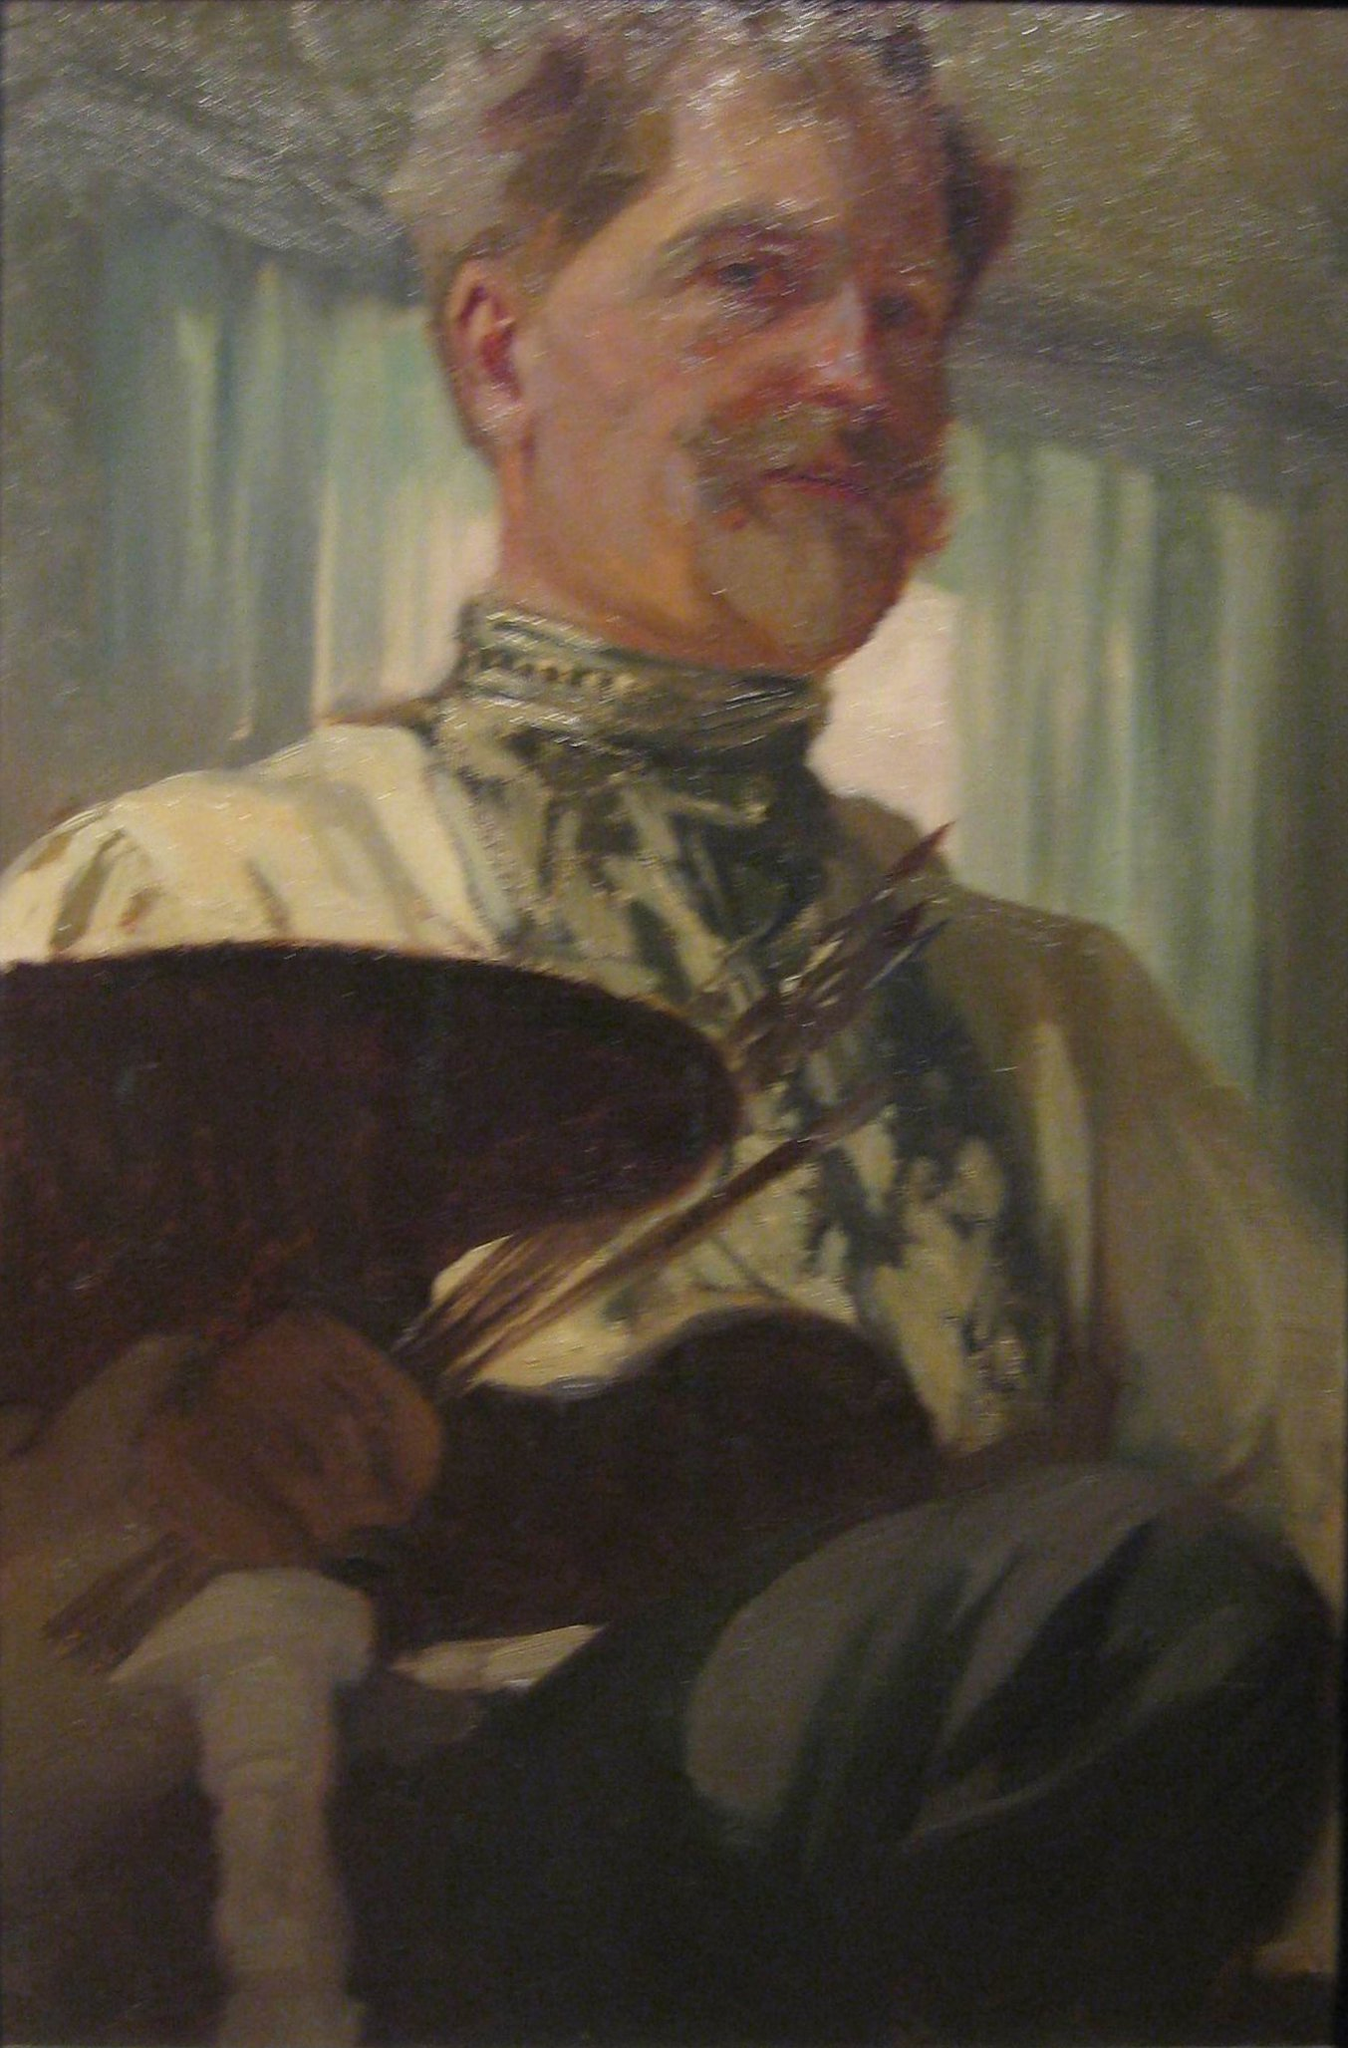Imagine if the scene in the painting came to life. Describe what might happen. If the scene in the painting came to life, we might witness a fascinating scene of the artist at work in his studio. Surrounded by the tools of his trade, he might pick up his palette and brushes with practiced ease, moving gracefully as he adds strokes of color to a canvas we cannot see. Perhaps he would hum softly or mutter to himself as he worked, lost in the world of creation. The curtain might sway gently with a breeze from an open window, adding a touch of movement to the otherwise still room. The artist might occasionally step back to admire his work, wiping his brow and smiling at the emerging image. This living scene would be filled with the quiet sounds of brush on canvas, the rustle of fabric, and the subtle, smoky scent of oil paint. 